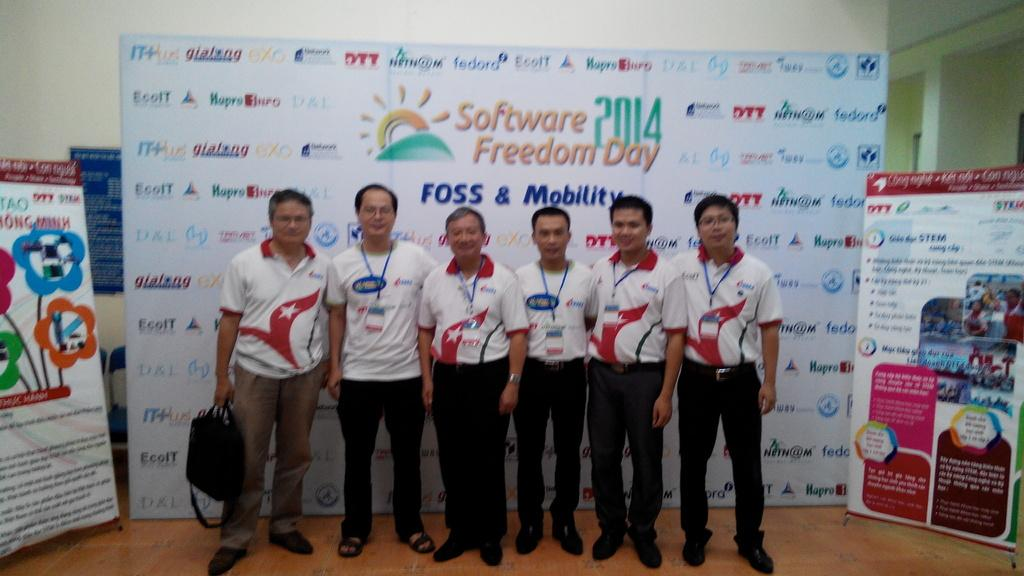<image>
Relay a brief, clear account of the picture shown. A group of men standing in front of a display at Software Freedom Day 2014 